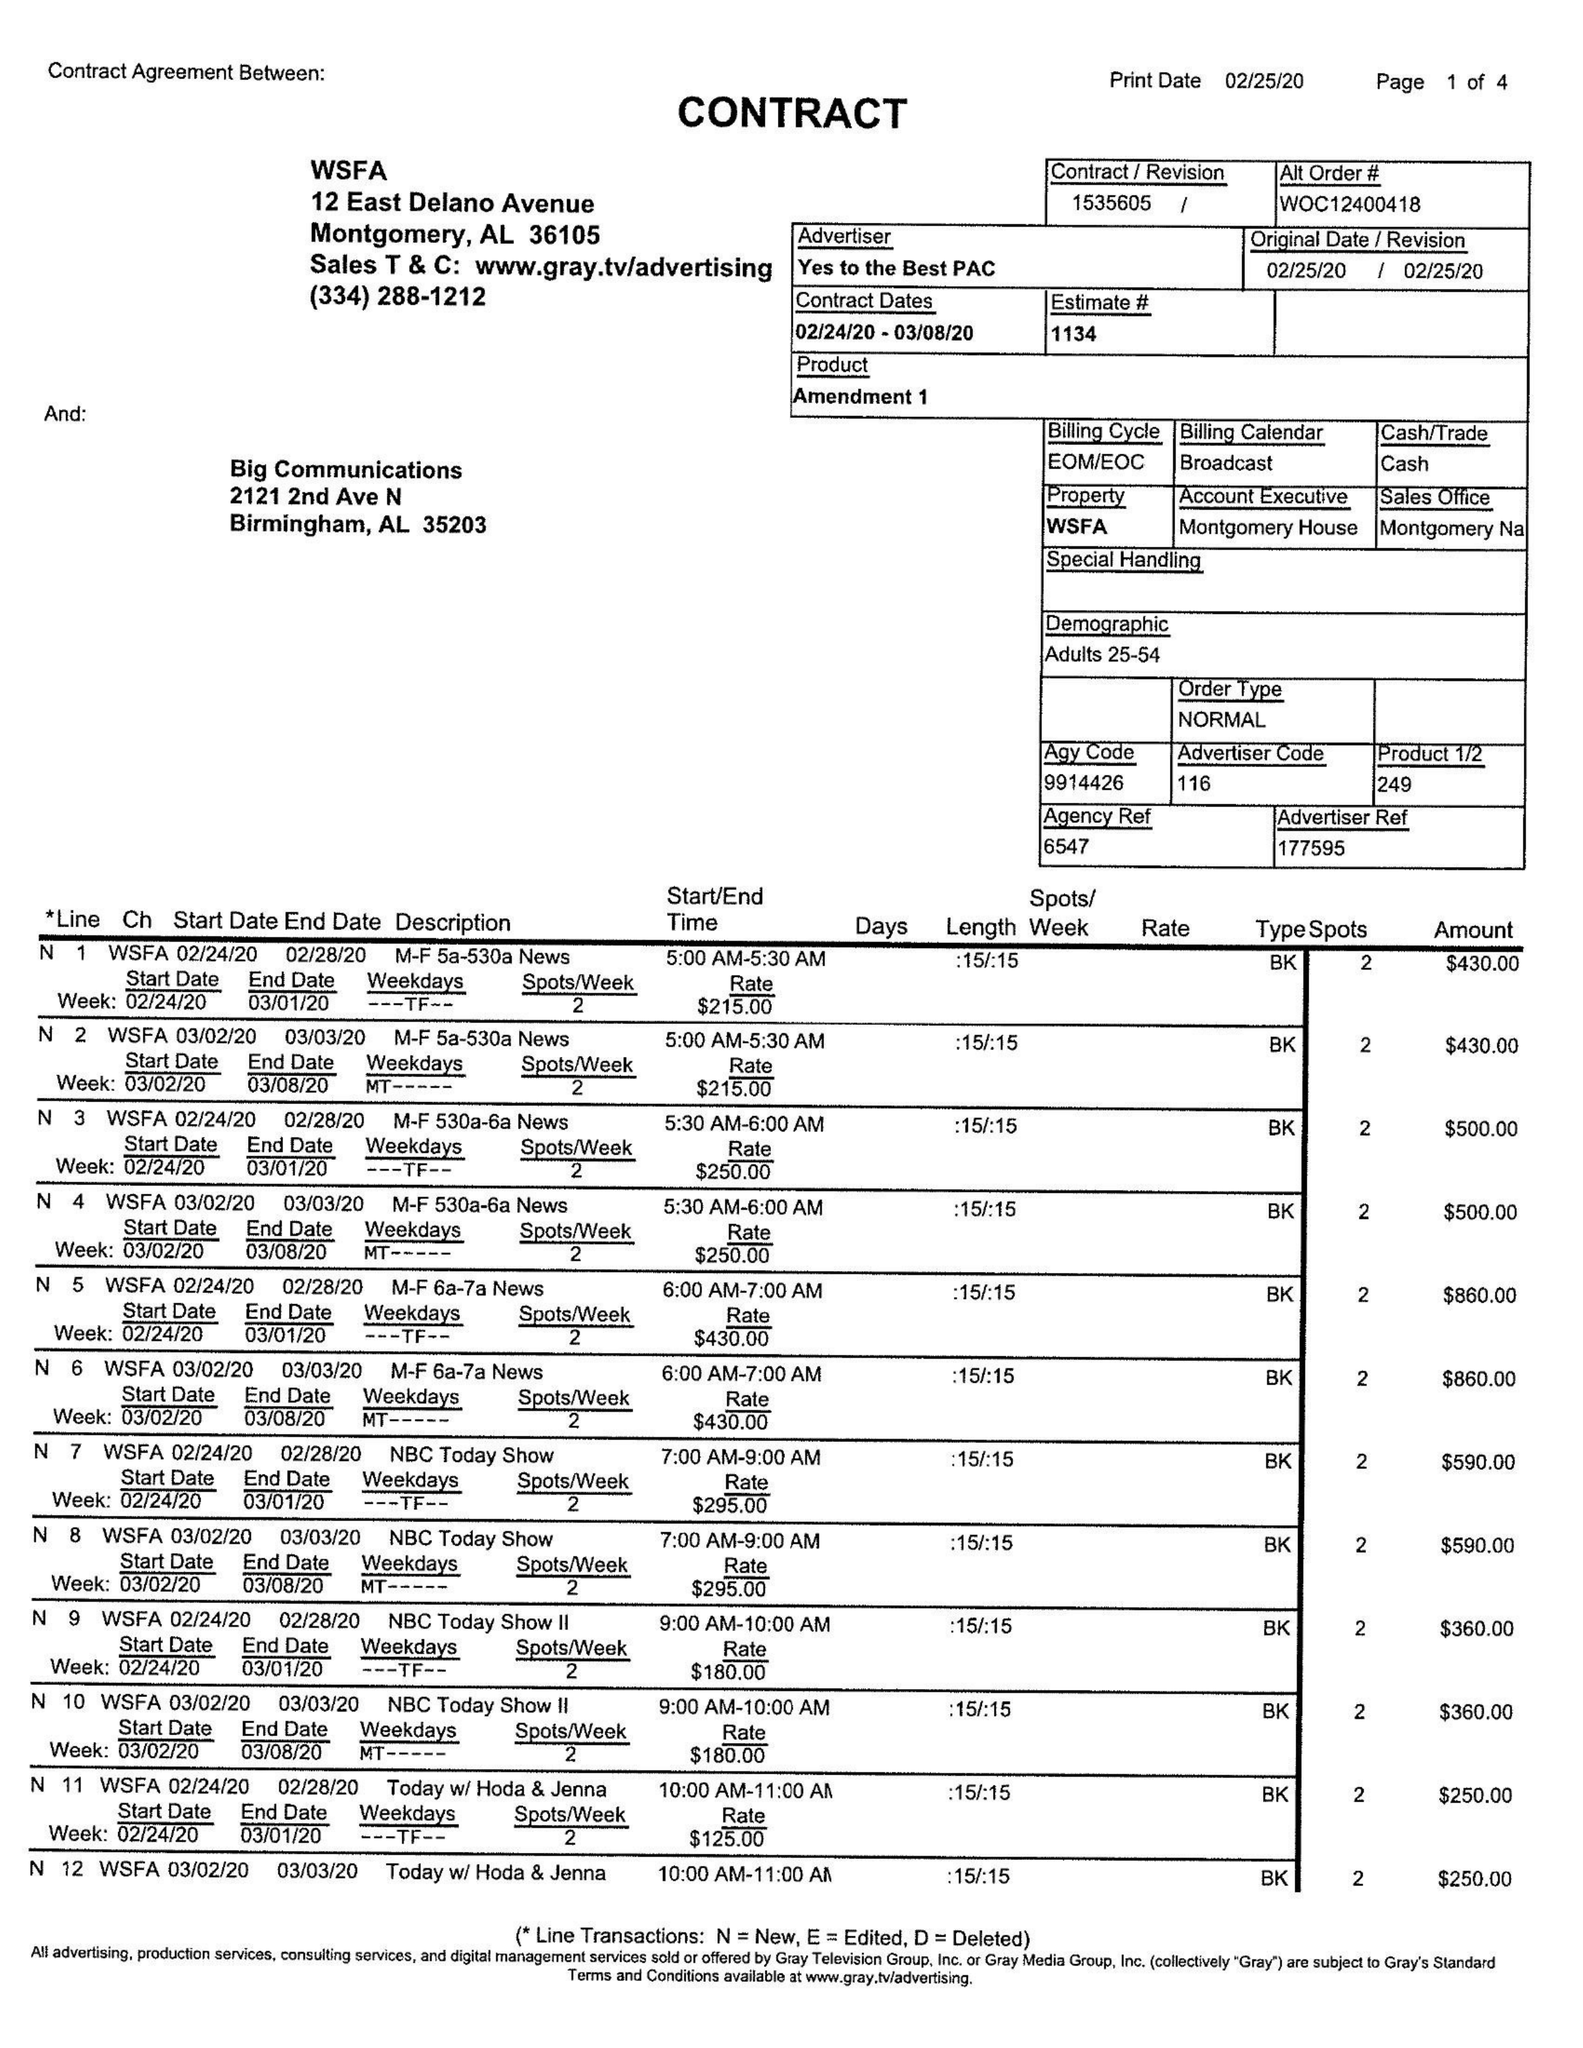What is the value for the flight_from?
Answer the question using a single word or phrase. 02/24/20 